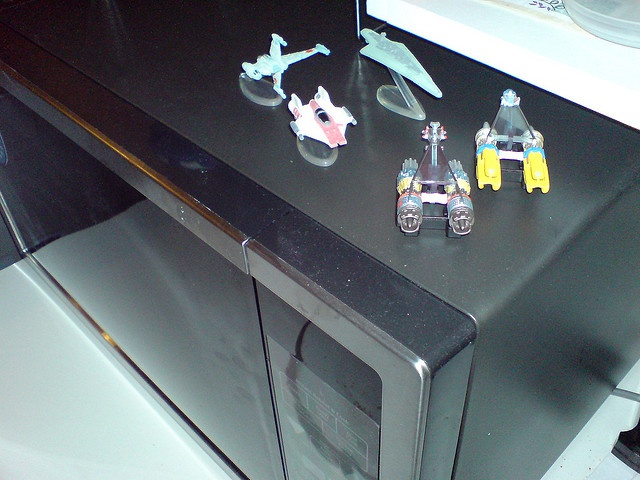Describe the objects in this image and their specific colors. I can see a microwave in gray, black, purple, and darkgray tones in this image. 